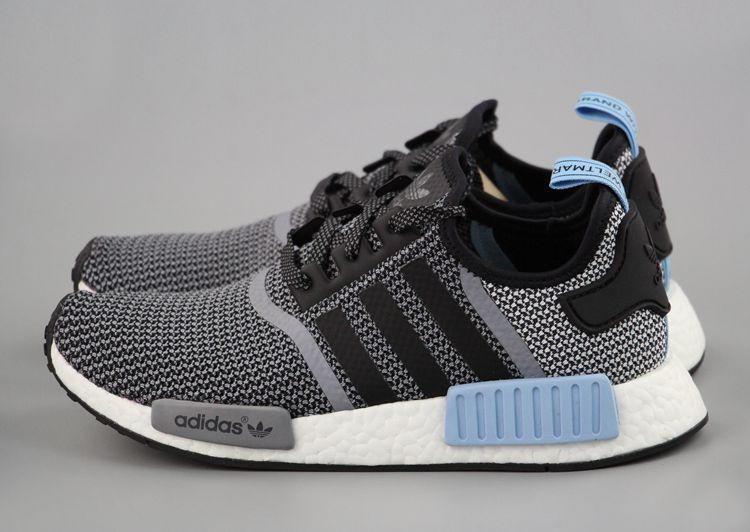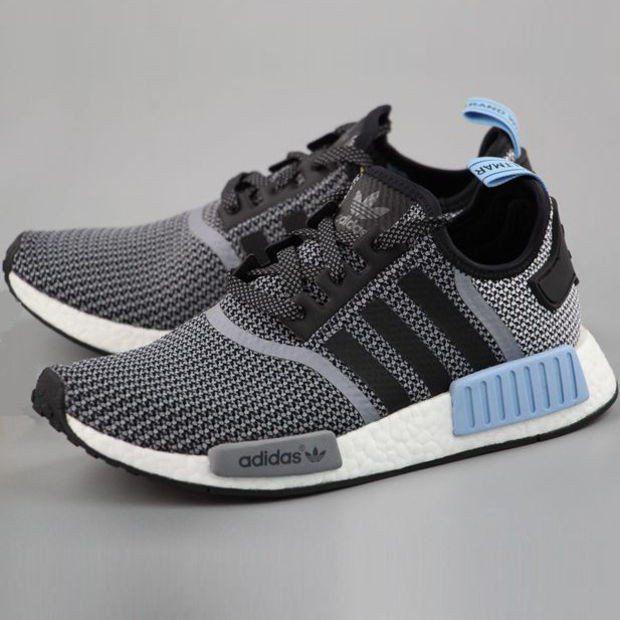The first image is the image on the left, the second image is the image on the right. For the images displayed, is the sentence "At least one image has more than one sneaker in it." factually correct? Answer yes or no. Yes. 